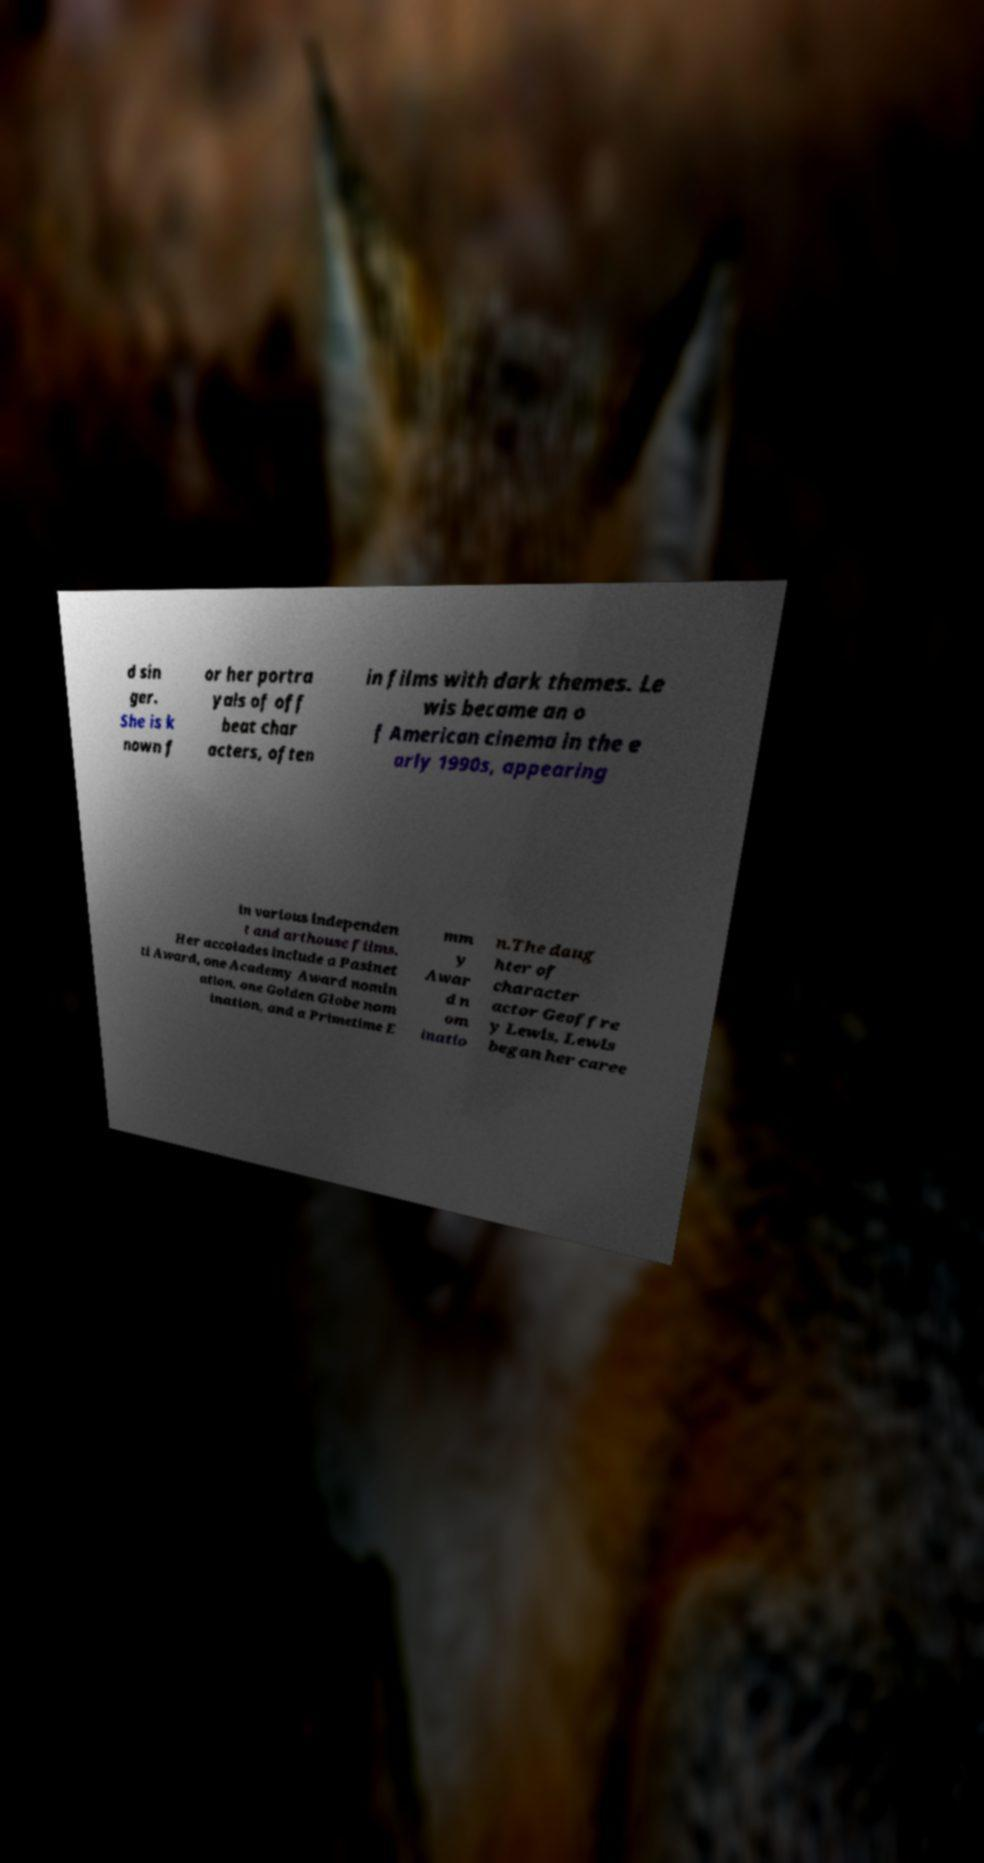What messages or text are displayed in this image? I need them in a readable, typed format. d sin ger. She is k nown f or her portra yals of off beat char acters, often in films with dark themes. Le wis became an o f American cinema in the e arly 1990s, appearing in various independen t and arthouse films. Her accolades include a Pasinet ti Award, one Academy Award nomin ation, one Golden Globe nom ination, and a Primetime E mm y Awar d n om inatio n.The daug hter of character actor Geoffre y Lewis, Lewis began her caree 